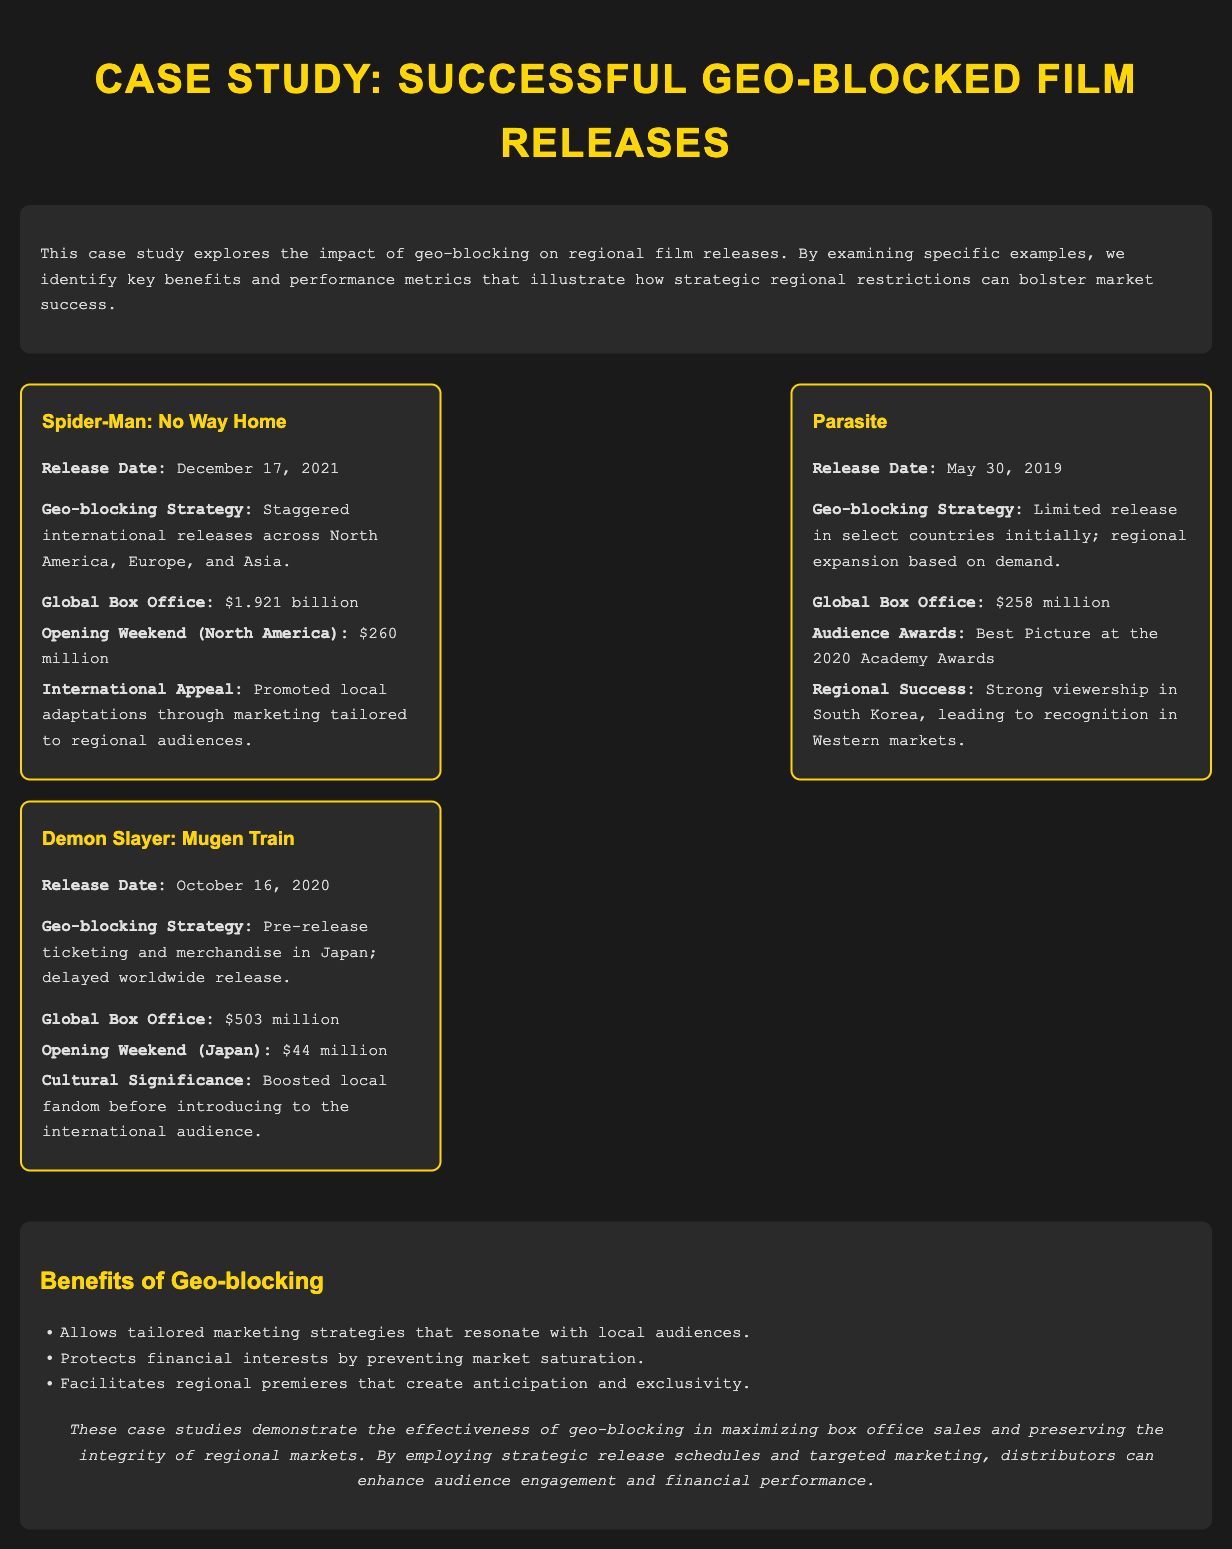What is the global box office for Spider-Man: No Way Home? The global box office is listed in the document under the metrics for Spider-Man: No Way Home.
Answer: $1.921 billion What was the release date of Parasite? The release date is provided in the film card for Parasite in the document.
Answer: May 30, 2019 What geo-blocking strategy was used for Demon Slayer: Mugen Train? The strategy is described in the film card for Demon Slayer: Mugen Train, outlining how the release was handled.
Answer: Pre-release ticketing and merchandise in Japan; delayed worldwide release What audience award did Parasite win? The award is mentioned under the metrics for Parasite in the document.
Answer: Best Picture at the 2020 Academy Awards What is the opening weekend revenue for Demon Slayer: Mugen Train in Japan? The opening weekend revenue is indicated in the film card for Demon Slayer: Mugen Train.
Answer: $44 million How much was the global box office for Parasite? The global box office amount for Parasite is provided in the document under its metrics.
Answer: $258 million What is one benefit of geo-blocking mentioned in the analysis? The benefits are grouped in a list format in the analysis section of the document.
Answer: Tailored marketing strategies How does geo-blocking protect financial interests? The reasoning is outlined in the benefits section of the analysis, explaining its effect on market condition.
Answer: Prevents market saturation What was the international appeal strategy for Spider-Man: No Way Home? The strategy is detailed in the metrics for Spider-Man: No Way Home in the document.
Answer: Promoted local adaptations through marketing tailored to regional audiences 